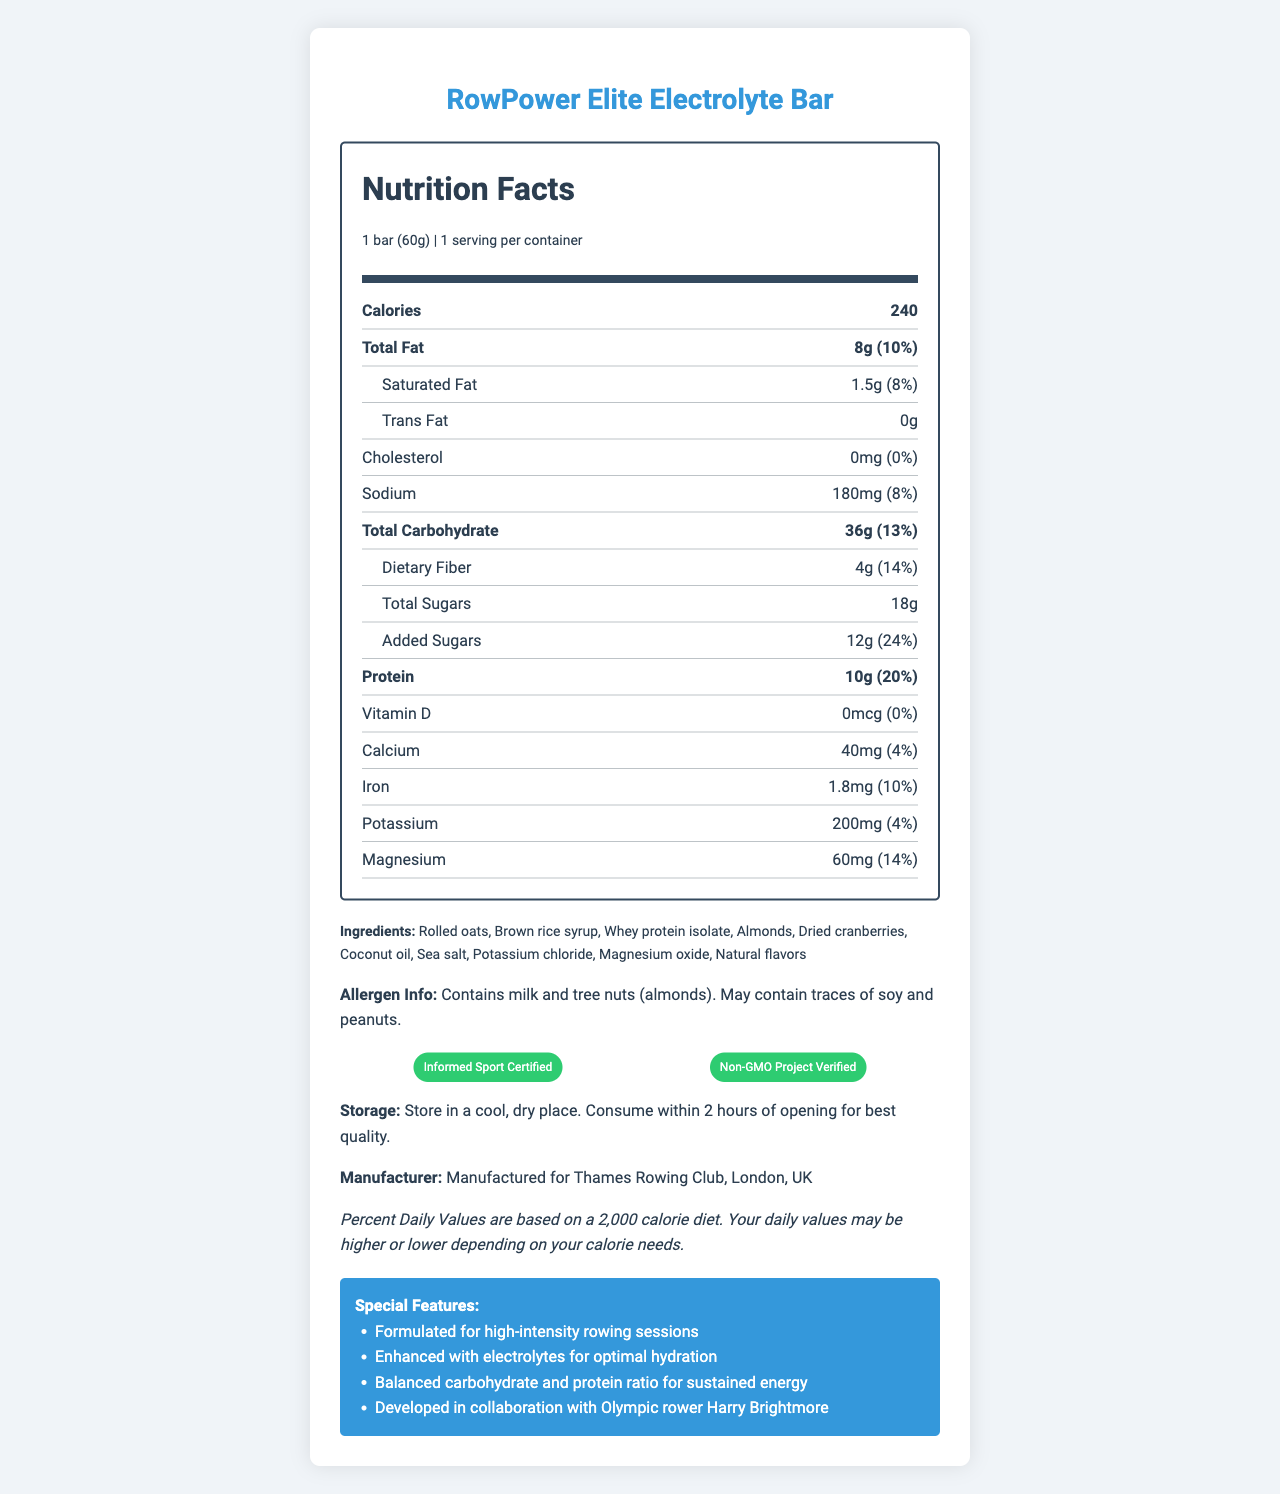who is the product manufacturer? The manufacturer information is listed under "Manufacturer Info" in the document.
Answer: Thames Rowing Club, London, UK what is the amount of protein in one serving of the RowPower Elite Electrolyte Bar? The protein amount is listed under the "Protein" section in the Nutrition Facts label.
Answer: 10g how many calories does one bar of RowPower Elite Electrolyte Bar contain? The calorie content is specified as 240 calories in the Nutrition Facts section.
Answer: 240 calories which certifications does the RowPower Elite Electrolyte Bar have? The certifications are listed under the "Certifications" section of the document.
Answer: Informed Sport Certified and Non-GMO Project Verified what are the special features of this energy bar? The special features are listed in the "Special Features" section.
Answer: Formulated for high-intensity rowing sessions, Enhanced with electrolytes for optimal hydration, Balanced carbohydrate and protein ratio for sustained energy, Developed in collaboration with Olympic rower Harry Brightmore what is the serving size for the RowPower Elite Electrolyte Bar? A. 30g B. 50g C. 60g D. 75g The serving size is specified as "1 bar (60g)" in the Nutrition Facts label.
Answer: C. 60g which ingredient is NOT present in the RowPower Elite Electrolyte Bar? A. Rolled oats B. Dried cranberries C. Whey protein isolate D. Almond butter Almond butter is not listed in the ingredients section, while the other options are.
Answer: D. Almond butter is the RowPower Elite Electrolyte Bar suitable for those with peanut allergies? The allergen information states that the bar may contain traces of peanuts.
Answer: No summarize the main idea of the document. The document includes comprehensive details on the energy bar's nutritional facts, certifications, special features, and more, aimed at high-performance rowing athletes.
Answer: The document provides detailed nutritional information, ingredients, special features, allergen info, certifications, and storage instructions for the RowPower Elite Electrolyte Bar, designed specifically for high-intensity rowing sessions and developed with Harry Brightmore's collaboration. can people with lactose intolerance consume this product? While the allergen info says the bar contains milk, it doesn't specify the amount of lactose present, making it unclear if it's safe for lactose-intolerant individuals.
Answer: Not enough information 